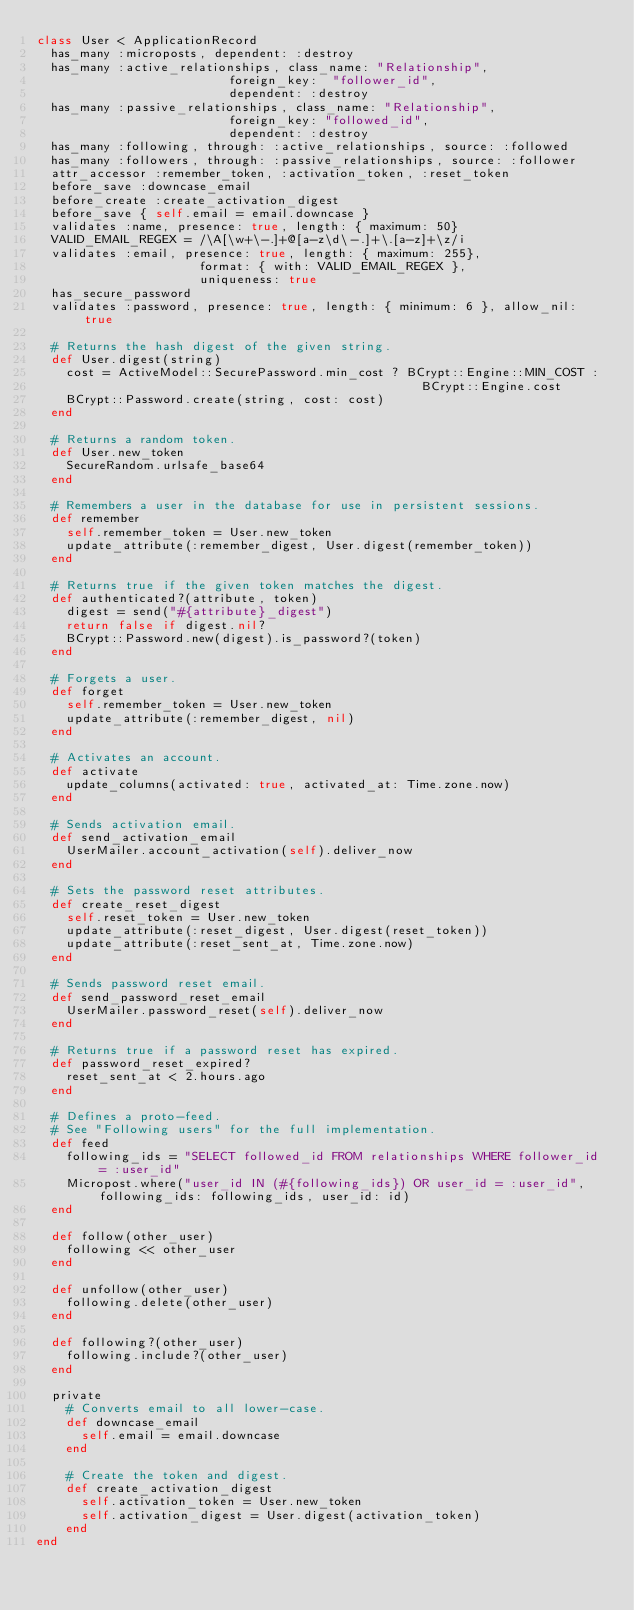Convert code to text. <code><loc_0><loc_0><loc_500><loc_500><_Ruby_>class User < ApplicationRecord
  has_many :microposts, dependent: :destroy
  has_many :active_relationships, class_name: "Relationship",
                          foreign_key:  "follower_id",
                          dependent: :destroy
  has_many :passive_relationships, class_name: "Relationship", 
                          foreign_key: "followed_id",
                          dependent: :destroy
  has_many :following, through: :active_relationships, source: :followed
  has_many :followers, through: :passive_relationships, source: :follower 
  attr_accessor :remember_token, :activation_token, :reset_token
  before_save :downcase_email
  before_create :create_activation_digest
  before_save { self.email = email.downcase }
  validates :name, presence: true, length: { maximum: 50}
  VALID_EMAIL_REGEX = /\A[\w+\-.]+@[a-z\d\-.]+\.[a-z]+\z/i
  validates :email, presence: true, length: { maximum: 255}, 
                      format: { with: VALID_EMAIL_REGEX },
                      uniqueness: true
  has_secure_password
  validates :password, presence: true, length: { minimum: 6 }, allow_nil: true 
  
  # Returns the hash digest of the given string.
  def User.digest(string)
    cost = ActiveModel::SecurePassword.min_cost ? BCrypt::Engine::MIN_COST :
                                                    BCrypt::Engine.cost
    BCrypt::Password.create(string, cost: cost)
  end
    
  # Returns a random token.
  def User.new_token
    SecureRandom.urlsafe_base64
  end
  
  # Remembers a user in the database for use in persistent sessions.
  def remember
    self.remember_token = User.new_token
    update_attribute(:remember_digest, User.digest(remember_token))
  end
  
  # Returns true if the given token matches the digest.
  def authenticated?(attribute, token)
    digest = send("#{attribute}_digest")
    return false if digest.nil?
    BCrypt::Password.new(digest).is_password?(token)
  end
  
  # Forgets a user.
  def forget 
    self.remember_token = User.new_token
    update_attribute(:remember_digest, nil)
  end
  
  # Activates an account.
  def activate
    update_columns(activated: true, activated_at: Time.zone.now)
  end 
  
  # Sends activation email.
  def send_activation_email
    UserMailer.account_activation(self).deliver_now
  end
  
  # Sets the password reset attributes.
  def create_reset_digest
    self.reset_token = User.new_token
    update_attribute(:reset_digest, User.digest(reset_token))
    update_attribute(:reset_sent_at, Time.zone.now)
  end
  
  # Sends password reset email.
  def send_password_reset_email
    UserMailer.password_reset(self).deliver_now
  end

  # Returns true if a password reset has expired.
  def password_reset_expired?
    reset_sent_at < 2.hours.ago
  end
  
  # Defines a proto-feed.
  # See "Following users" for the full implementation.
  def feed 
    following_ids = "SELECT followed_id FROM relationships WHERE follower_id = :user_id"
    Micropost.where("user_id IN (#{following_ids}) OR user_id = :user_id", following_ids: following_ids, user_id: id)  
  end 
  
  def follow(other_user)
    following << other_user
  end 
  
  def unfollow(other_user)
    following.delete(other_user)
  end 
  
  def following?(other_user)
    following.include?(other_user)
  end 

  private 
    # Converts email to all lower-case.
    def downcase_email
      self.email = email.downcase
    end 
    
    # Create the token and digest.
    def create_activation_digest
      self.activation_token = User.new_token
      self.activation_digest = User.digest(activation_token)
    end
end
</code> 